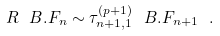<formula> <loc_0><loc_0><loc_500><loc_500>R \ B . F _ { n } \sim \tau _ { n + 1 , 1 } ^ { ( p + 1 ) } \ B . F _ { n + 1 } \ .</formula> 